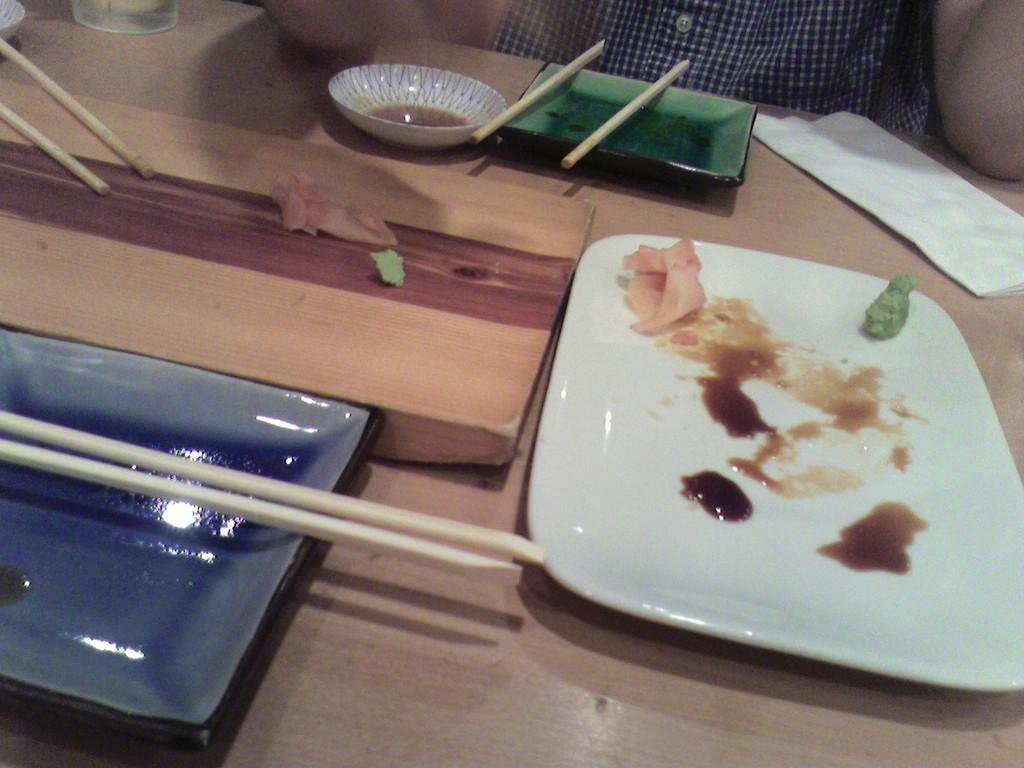What is on the plate in the image? There is an empty plate with leftover food in the image. What else can be seen on the table besides the plate? There is a bowl and chopsticks visible in the image. What might be used for cleaning or wiping in the image? Tissue is present in the image for cleaning or wiping. Where are all these items located? All of these items are on a table. What type of furniture is visible in the image? There is no furniture visible in the image; only a table with various items is present. Can you tell me which playground is shown in the image? There is no playground present in the image. 